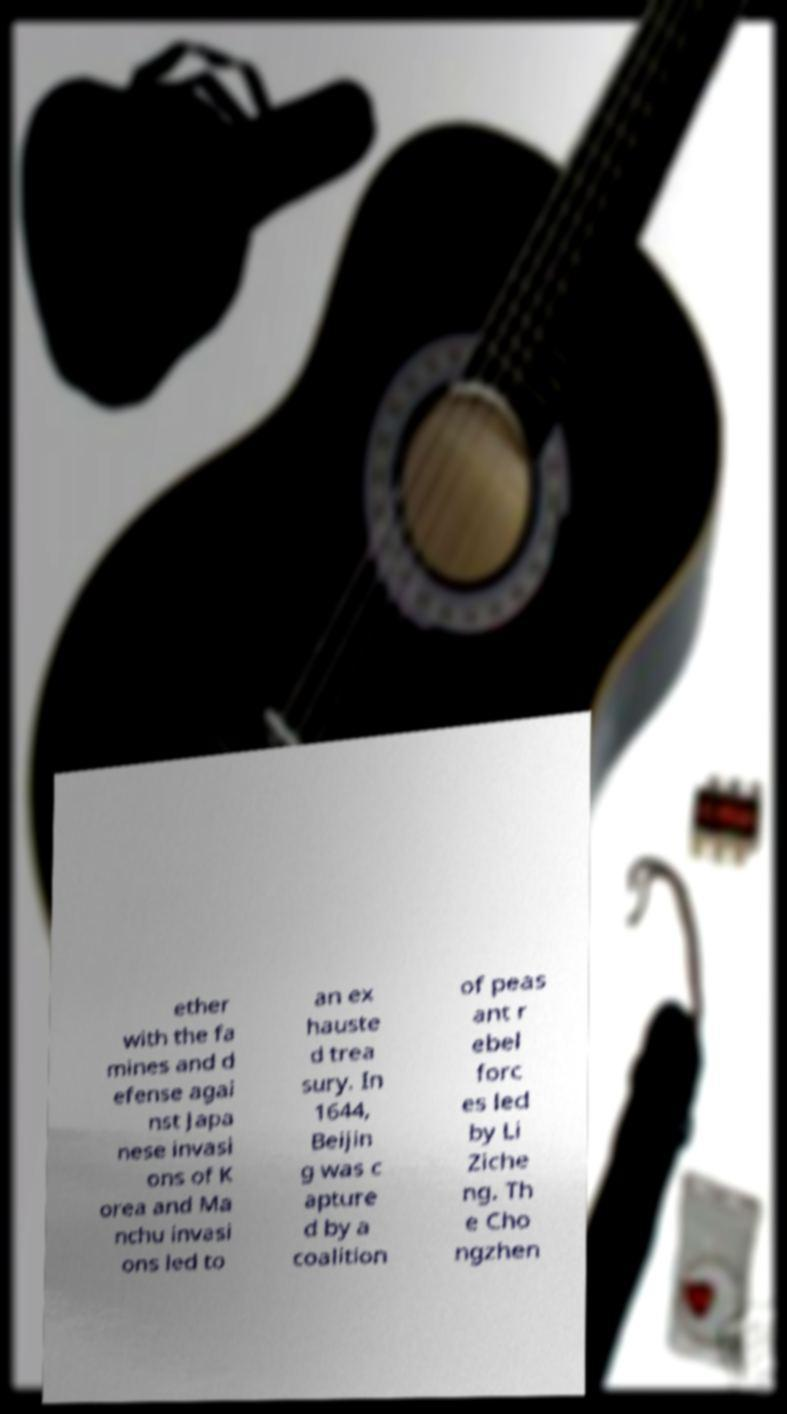Please identify and transcribe the text found in this image. ether with the fa mines and d efense agai nst Japa nese invasi ons of K orea and Ma nchu invasi ons led to an ex hauste d trea sury. In 1644, Beijin g was c apture d by a coalition of peas ant r ebel forc es led by Li Ziche ng. Th e Cho ngzhen 